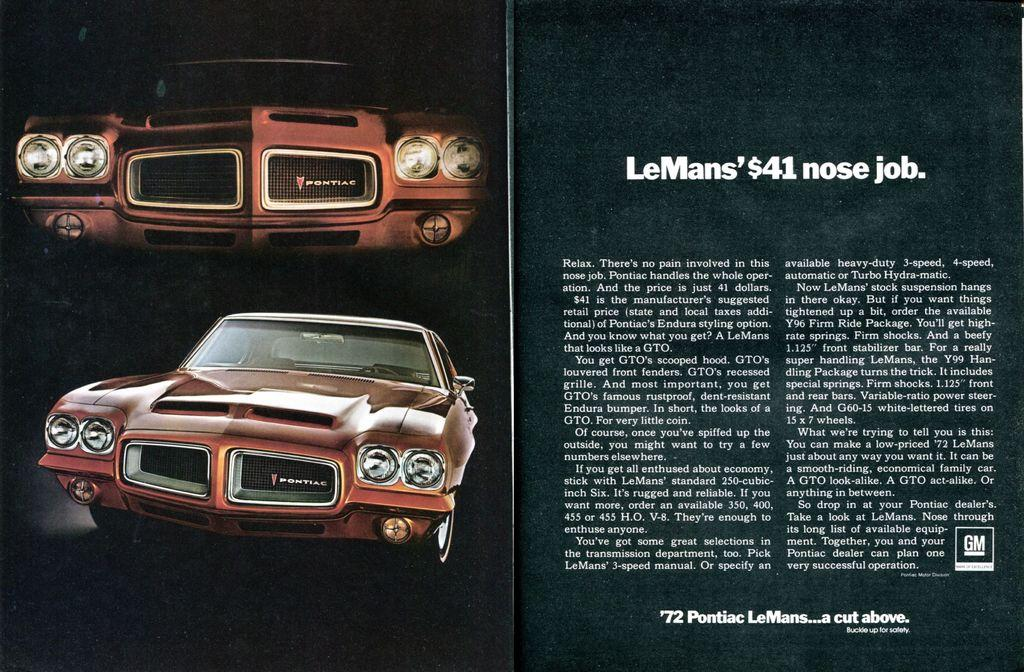What can be seen on the left side of the image? There are two car images on the left side of the image. What is present on the right side of the image? There is some text on the right side of the image. Can you tell me how many beetles are crawling on the car images in the picture? There are no beetles present in the image; it features two car images and some text. What type of rifle is depicted in the image? There is no rifle present in the image. 